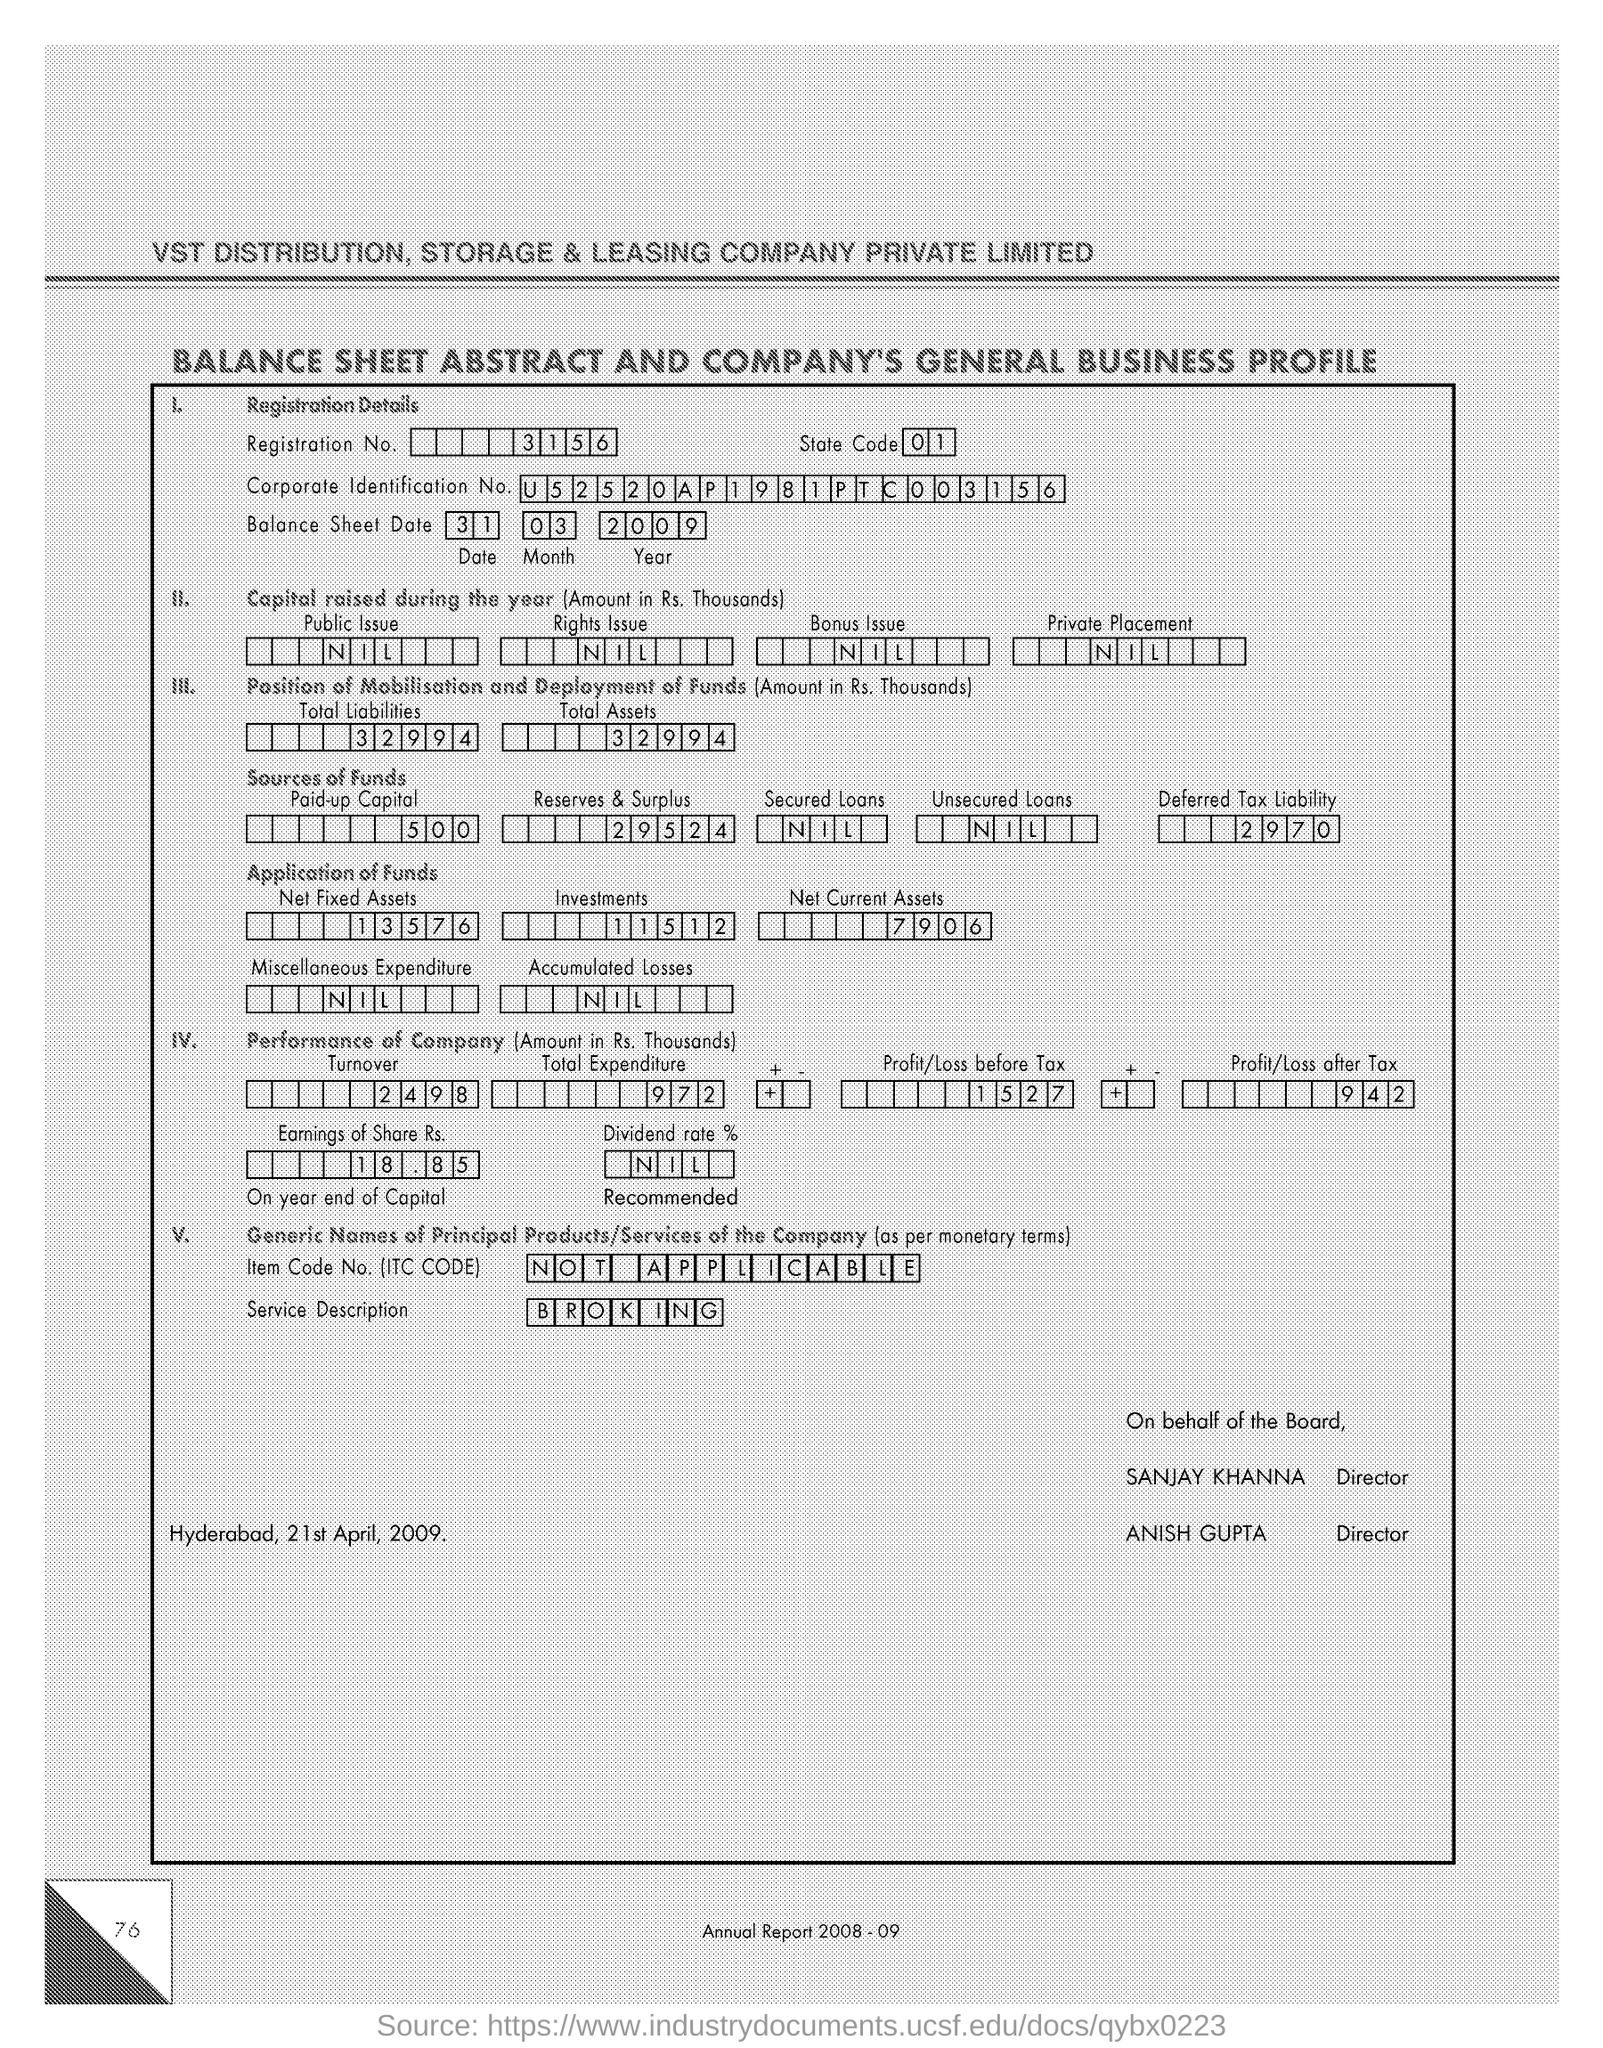Point out several critical features in this image. After taxes, the profit/loss is 942. The Dividend rate field contains the value NIL, The registration number is 3156... The Corporate Identification Number is a unique number assigned to a company for official purposes. The given number, U52520AP1981PTC003156, is an example of a Corporate Identification Number. The information provided in the "Service Description" field is "BROKING..". 